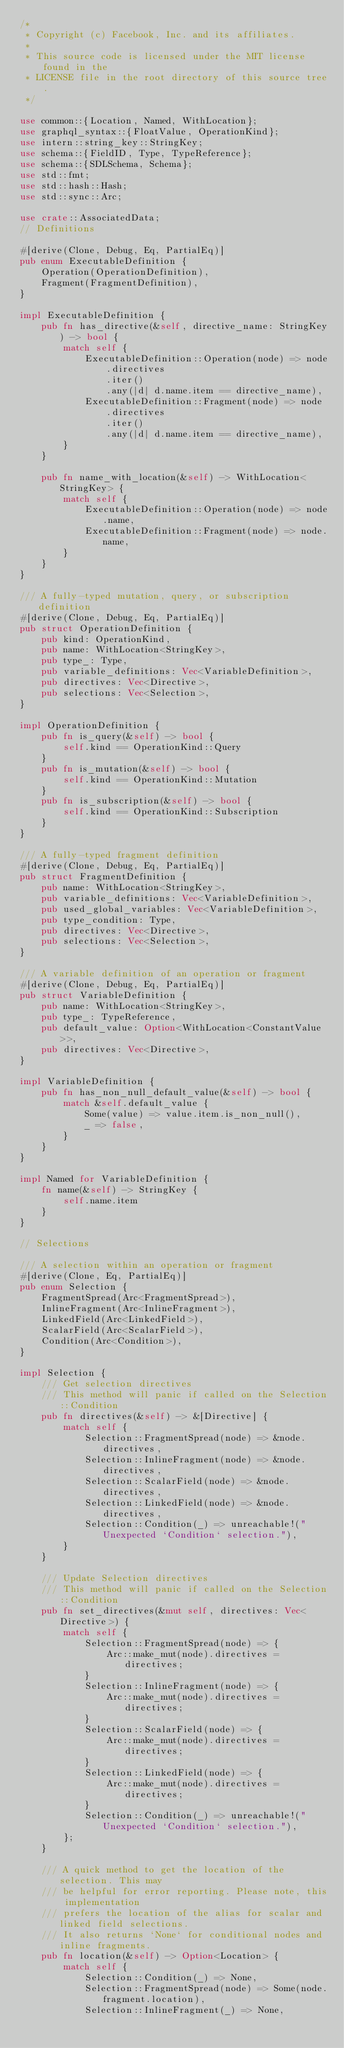<code> <loc_0><loc_0><loc_500><loc_500><_Rust_>/*
 * Copyright (c) Facebook, Inc. and its affiliates.
 *
 * This source code is licensed under the MIT license found in the
 * LICENSE file in the root directory of this source tree.
 */

use common::{Location, Named, WithLocation};
use graphql_syntax::{FloatValue, OperationKind};
use intern::string_key::StringKey;
use schema::{FieldID, Type, TypeReference};
use schema::{SDLSchema, Schema};
use std::fmt;
use std::hash::Hash;
use std::sync::Arc;

use crate::AssociatedData;
// Definitions

#[derive(Clone, Debug, Eq, PartialEq)]
pub enum ExecutableDefinition {
    Operation(OperationDefinition),
    Fragment(FragmentDefinition),
}

impl ExecutableDefinition {
    pub fn has_directive(&self, directive_name: StringKey) -> bool {
        match self {
            ExecutableDefinition::Operation(node) => node
                .directives
                .iter()
                .any(|d| d.name.item == directive_name),
            ExecutableDefinition::Fragment(node) => node
                .directives
                .iter()
                .any(|d| d.name.item == directive_name),
        }
    }

    pub fn name_with_location(&self) -> WithLocation<StringKey> {
        match self {
            ExecutableDefinition::Operation(node) => node.name,
            ExecutableDefinition::Fragment(node) => node.name,
        }
    }
}

/// A fully-typed mutation, query, or subscription definition
#[derive(Clone, Debug, Eq, PartialEq)]
pub struct OperationDefinition {
    pub kind: OperationKind,
    pub name: WithLocation<StringKey>,
    pub type_: Type,
    pub variable_definitions: Vec<VariableDefinition>,
    pub directives: Vec<Directive>,
    pub selections: Vec<Selection>,
}

impl OperationDefinition {
    pub fn is_query(&self) -> bool {
        self.kind == OperationKind::Query
    }
    pub fn is_mutation(&self) -> bool {
        self.kind == OperationKind::Mutation
    }
    pub fn is_subscription(&self) -> bool {
        self.kind == OperationKind::Subscription
    }
}

/// A fully-typed fragment definition
#[derive(Clone, Debug, Eq, PartialEq)]
pub struct FragmentDefinition {
    pub name: WithLocation<StringKey>,
    pub variable_definitions: Vec<VariableDefinition>,
    pub used_global_variables: Vec<VariableDefinition>,
    pub type_condition: Type,
    pub directives: Vec<Directive>,
    pub selections: Vec<Selection>,
}

/// A variable definition of an operation or fragment
#[derive(Clone, Debug, Eq, PartialEq)]
pub struct VariableDefinition {
    pub name: WithLocation<StringKey>,
    pub type_: TypeReference,
    pub default_value: Option<WithLocation<ConstantValue>>,
    pub directives: Vec<Directive>,
}

impl VariableDefinition {
    pub fn has_non_null_default_value(&self) -> bool {
        match &self.default_value {
            Some(value) => value.item.is_non_null(),
            _ => false,
        }
    }
}

impl Named for VariableDefinition {
    fn name(&self) -> StringKey {
        self.name.item
    }
}

// Selections

/// A selection within an operation or fragment
#[derive(Clone, Eq, PartialEq)]
pub enum Selection {
    FragmentSpread(Arc<FragmentSpread>),
    InlineFragment(Arc<InlineFragment>),
    LinkedField(Arc<LinkedField>),
    ScalarField(Arc<ScalarField>),
    Condition(Arc<Condition>),
}

impl Selection {
    /// Get selection directives
    /// This method will panic if called on the Selection::Condition
    pub fn directives(&self) -> &[Directive] {
        match self {
            Selection::FragmentSpread(node) => &node.directives,
            Selection::InlineFragment(node) => &node.directives,
            Selection::ScalarField(node) => &node.directives,
            Selection::LinkedField(node) => &node.directives,
            Selection::Condition(_) => unreachable!("Unexpected `Condition` selection."),
        }
    }

    /// Update Selection directives
    /// This method will panic if called on the Selection::Condition
    pub fn set_directives(&mut self, directives: Vec<Directive>) {
        match self {
            Selection::FragmentSpread(node) => {
                Arc::make_mut(node).directives = directives;
            }
            Selection::InlineFragment(node) => {
                Arc::make_mut(node).directives = directives;
            }
            Selection::ScalarField(node) => {
                Arc::make_mut(node).directives = directives;
            }
            Selection::LinkedField(node) => {
                Arc::make_mut(node).directives = directives;
            }
            Selection::Condition(_) => unreachable!("Unexpected `Condition` selection."),
        };
    }

    /// A quick method to get the location of the selection. This may
    /// be helpful for error reporting. Please note, this implementation
    /// prefers the location of the alias for scalar and linked field selections.
    /// It also returns `None` for conditional nodes and inline fragments.
    pub fn location(&self) -> Option<Location> {
        match self {
            Selection::Condition(_) => None,
            Selection::FragmentSpread(node) => Some(node.fragment.location),
            Selection::InlineFragment(_) => None,</code> 